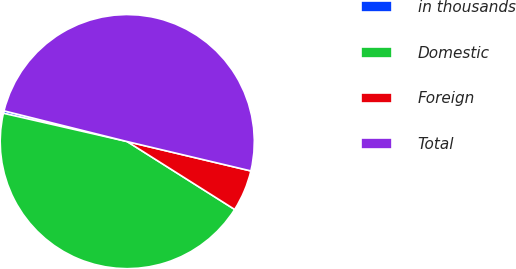<chart> <loc_0><loc_0><loc_500><loc_500><pie_chart><fcel>in thousands<fcel>Domestic<fcel>Foreign<fcel>Total<nl><fcel>0.31%<fcel>44.61%<fcel>5.26%<fcel>49.82%<nl></chart> 